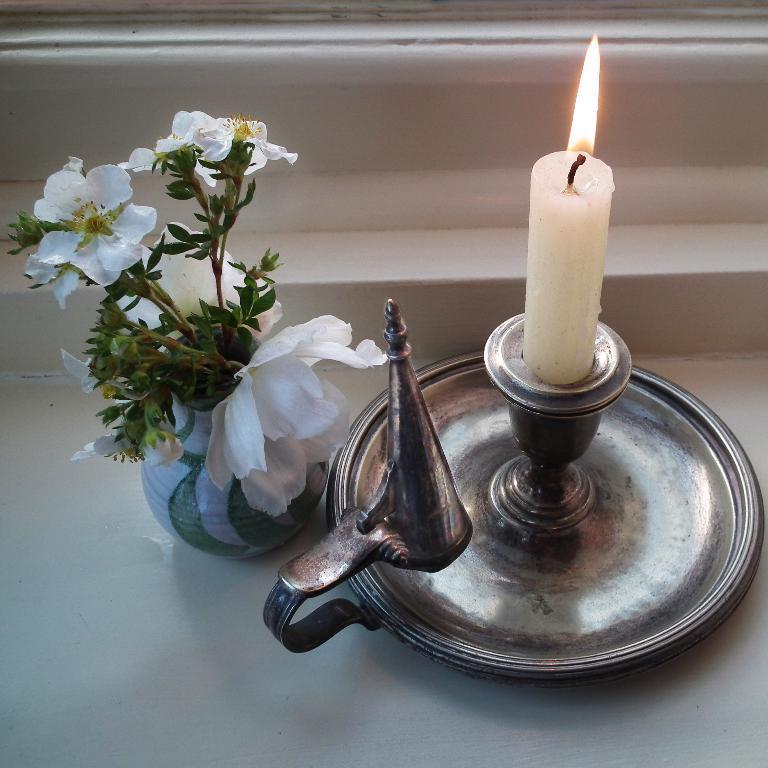Could you give a brief overview of what you see in this image? In this image I can see a candle stand and on it I can see a white colour candle. Here I can see few white colour flowers in a pot. 